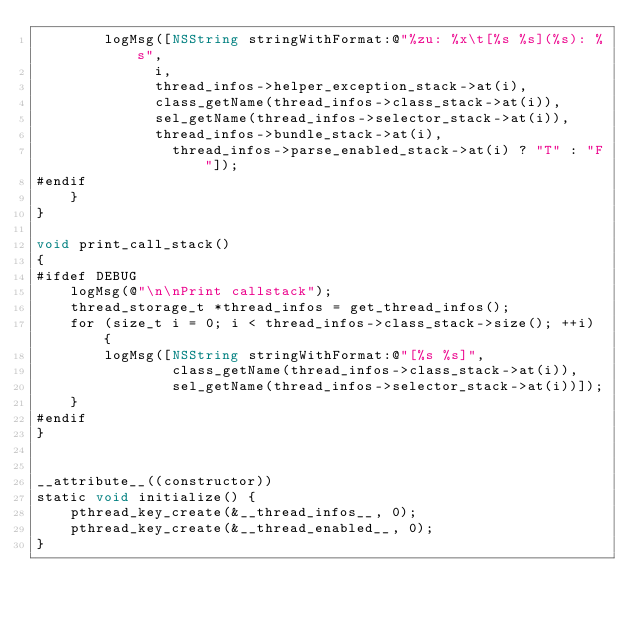<code> <loc_0><loc_0><loc_500><loc_500><_ObjectiveC_>        logMsg([NSString stringWithFormat:@"%zu: %x\t[%s %s](%s): %s",
              i,
              thread_infos->helper_exception_stack->at(i),
              class_getName(thread_infos->class_stack->at(i)),
              sel_getName(thread_infos->selector_stack->at(i)),
              thread_infos->bundle_stack->at(i),
                thread_infos->parse_enabled_stack->at(i) ? "T" : "F"]);
#endif
    }
}

void print_call_stack()
{
#ifdef DEBUG
    logMsg(@"\n\nPrint callstack");
    thread_storage_t *thread_infos = get_thread_infos();
    for (size_t i = 0; i < thread_infos->class_stack->size(); ++i) {
        logMsg([NSString stringWithFormat:@"[%s %s]",
                class_getName(thread_infos->class_stack->at(i)),
                sel_getName(thread_infos->selector_stack->at(i))]);
    }
#endif
}


__attribute__((constructor))
static void initialize() {
    pthread_key_create(&__thread_infos__, 0);
    pthread_key_create(&__thread_enabled__, 0);
}</code> 